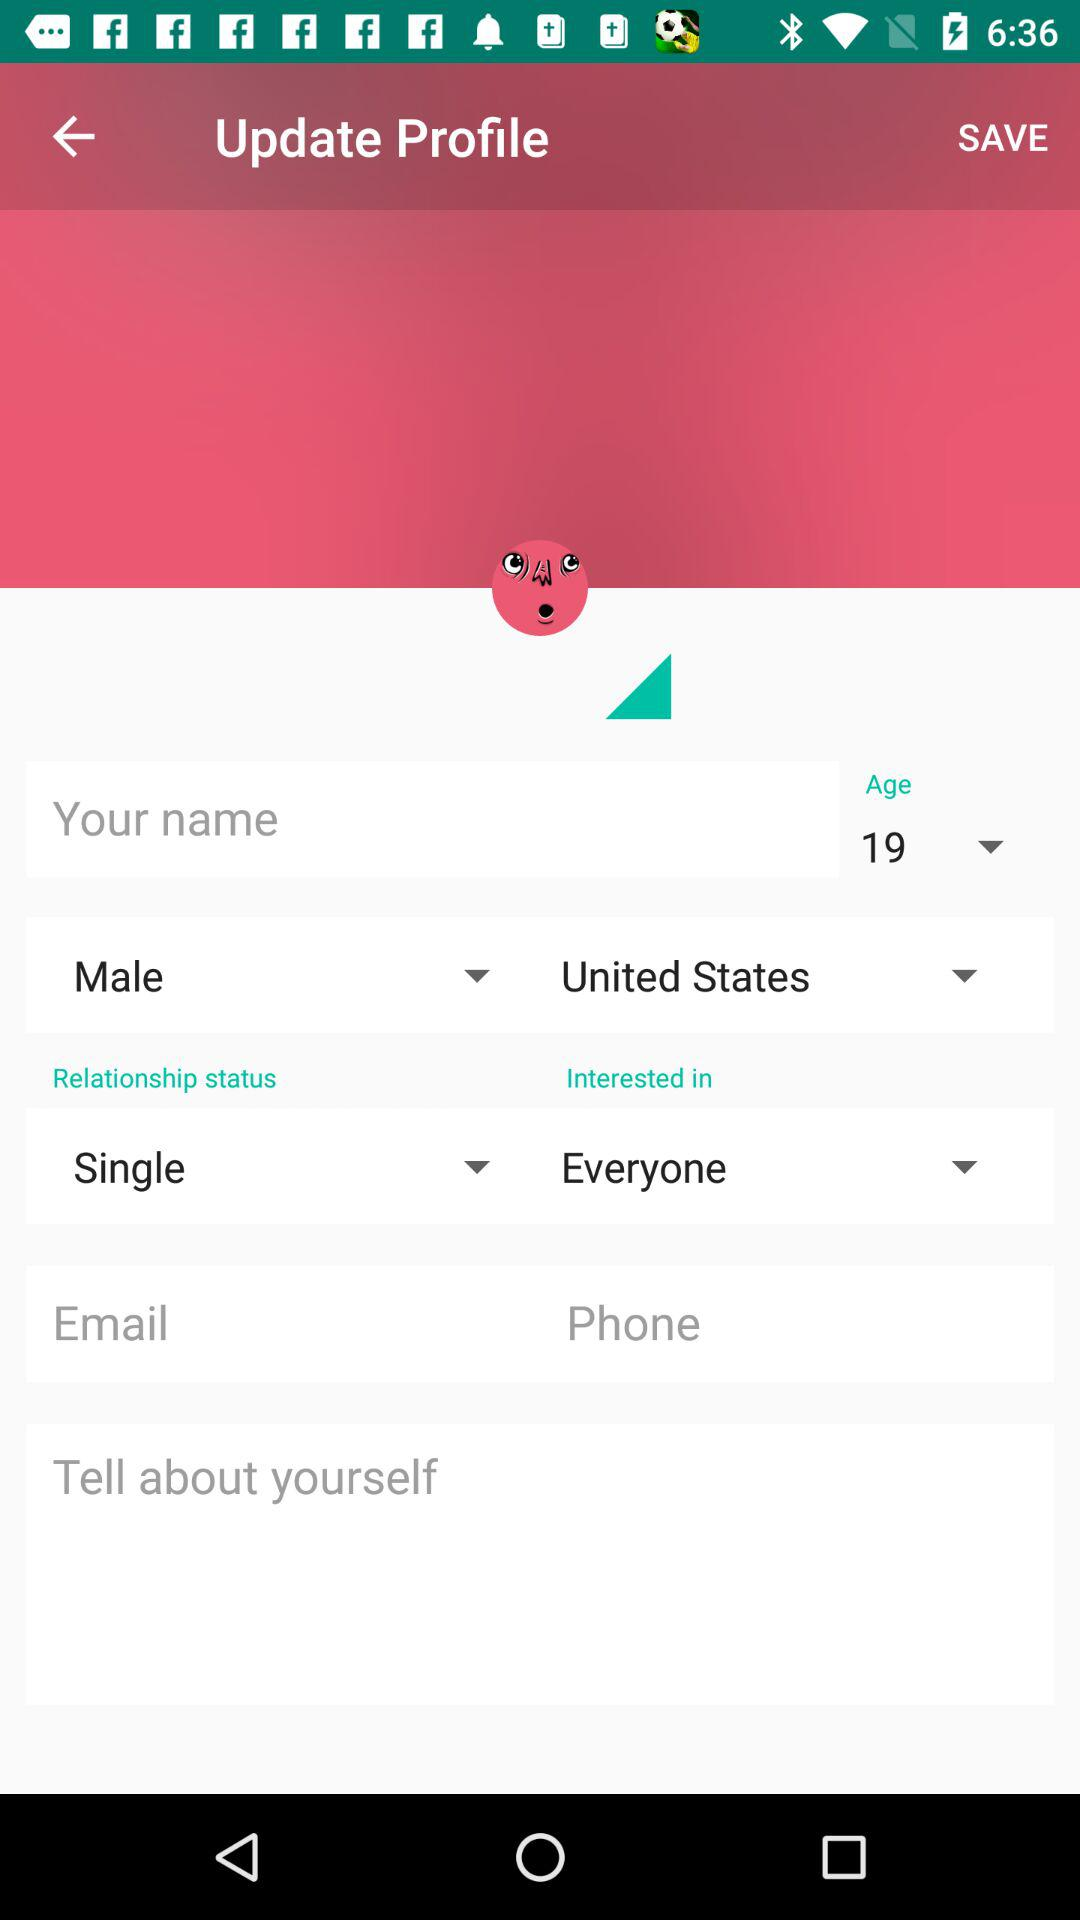What is your name?
When the provided information is insufficient, respond with <no answer>. <no answer> 